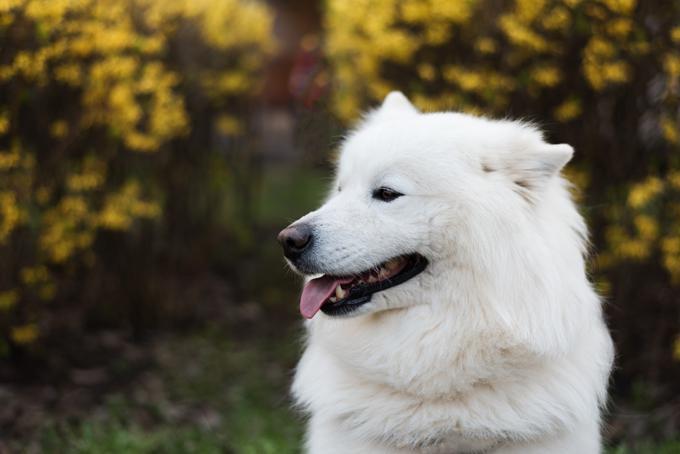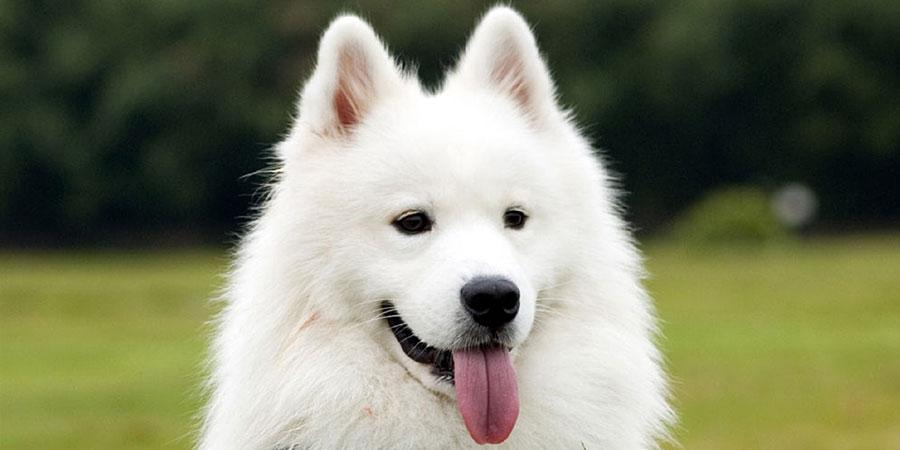The first image is the image on the left, the second image is the image on the right. For the images displayed, is the sentence "Combined, the images contain exactly four animals." factually correct? Answer yes or no. No. The first image is the image on the left, the second image is the image on the right. Analyze the images presented: Is the assertion "There are two dogs in the image on the left." valid? Answer yes or no. No. 